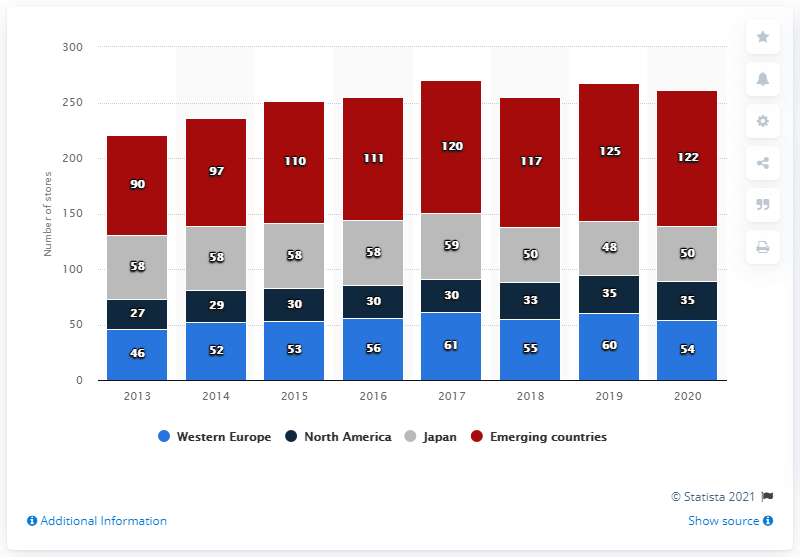Indicate a few pertinent items in this graphic. In 2020, Bottega Veneta operated 50 stores in Japan. In the year 2020, there were 122 directly operated Bottega Veneta stores in the Emerging Countries. The number of Bottega Veneta stores has seen a significant increase in emerging countries between 2013 and 2020. 